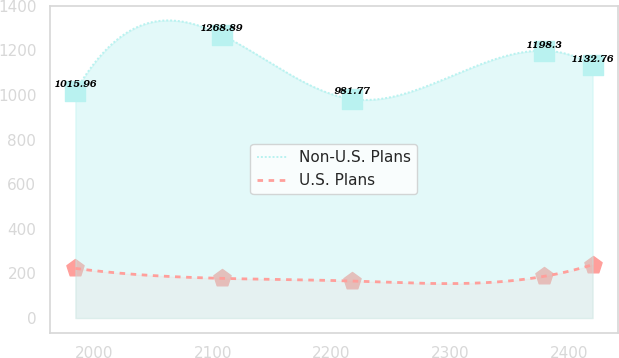Convert chart to OTSL. <chart><loc_0><loc_0><loc_500><loc_500><line_chart><ecel><fcel>Non-U.S. Plans<fcel>U.S. Plans<nl><fcel>1984.34<fcel>1015.96<fcel>222.55<nl><fcel>2107.44<fcel>1268.89<fcel>177.87<nl><fcel>2216.92<fcel>981.77<fcel>165.98<nl><fcel>2379.09<fcel>1198.3<fcel>187.02<nl><fcel>2419.89<fcel>1132.76<fcel>239.17<nl></chart> 